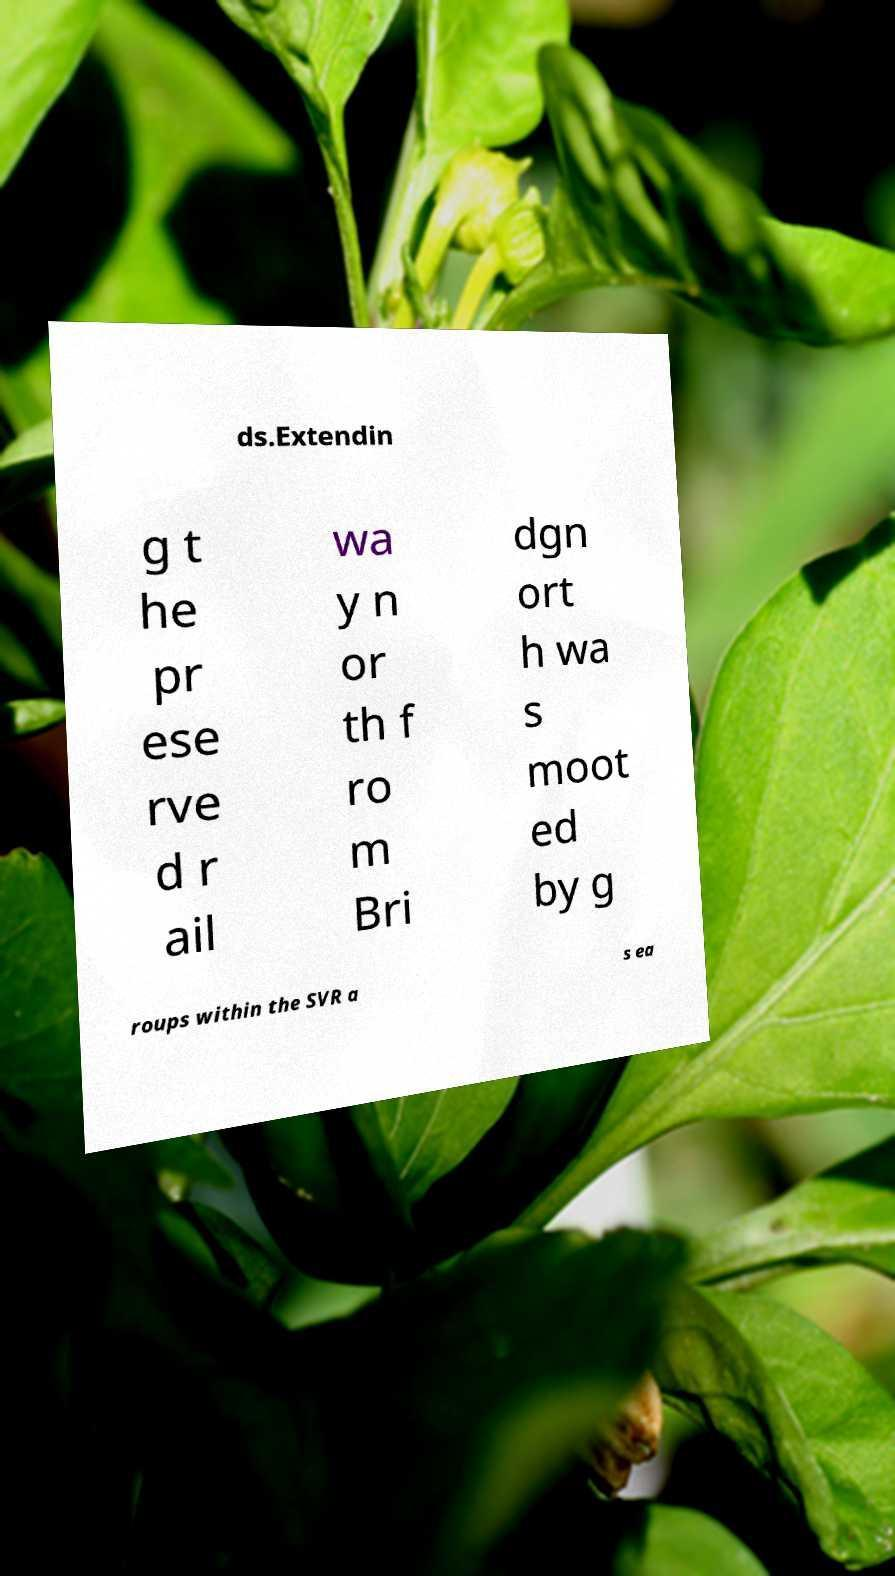Could you extract and type out the text from this image? ds.Extendin g t he pr ese rve d r ail wa y n or th f ro m Bri dgn ort h wa s moot ed by g roups within the SVR a s ea 